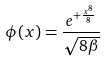<formula> <loc_0><loc_0><loc_500><loc_500>\phi ( x ) = \frac { e ^ { + \frac { x ^ { 8 } } { 8 } } } { \sqrt { 8 \beta } }</formula> 